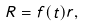<formula> <loc_0><loc_0><loc_500><loc_500>R = f ( t ) r ,</formula> 